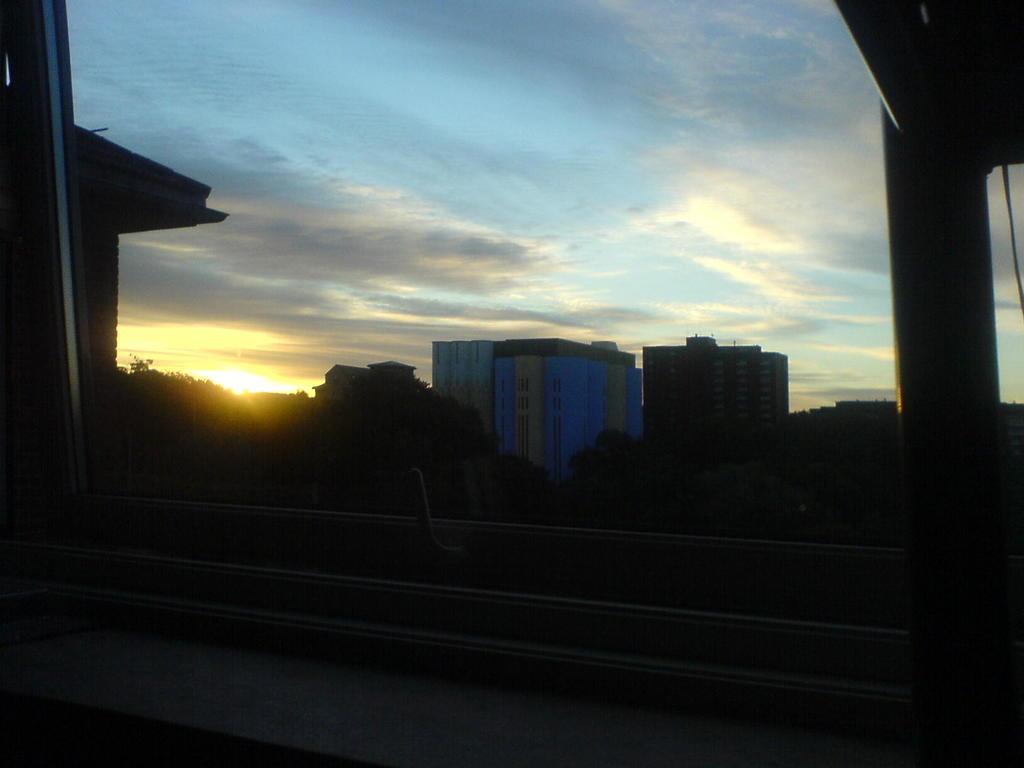Please provide a concise description of this image. Through this window we can see trees, building and sky. Sky is cloudy. 